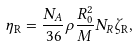Convert formula to latex. <formula><loc_0><loc_0><loc_500><loc_500>\eta _ { \text {R} } = \frac { N _ { A } } { 3 6 } \rho \frac { R _ { 0 } ^ { 2 } } { M } N _ { R } \zeta _ { \text {R} } ,</formula> 